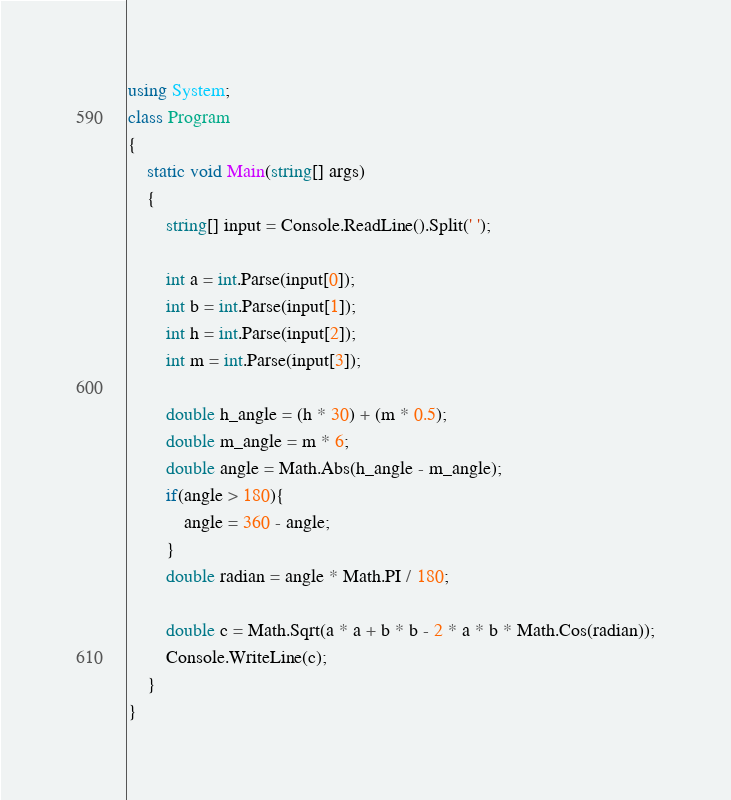Convert code to text. <code><loc_0><loc_0><loc_500><loc_500><_C#_>using System;
class Program
{
    static void Main(string[] args)
    {
        string[] input = Console.ReadLine().Split(' ');

        int a = int.Parse(input[0]);
        int b = int.Parse(input[1]);
        int h = int.Parse(input[2]);
        int m = int.Parse(input[3]);

        double h_angle = (h * 30) + (m * 0.5);
        double m_angle = m * 6;
        double angle = Math.Abs(h_angle - m_angle);
        if(angle > 180){
            angle = 360 - angle;
        }
        double radian = angle * Math.PI / 180;

        double c = Math.Sqrt(a * a + b * b - 2 * a * b * Math.Cos(radian));
        Console.WriteLine(c);
    }
}</code> 